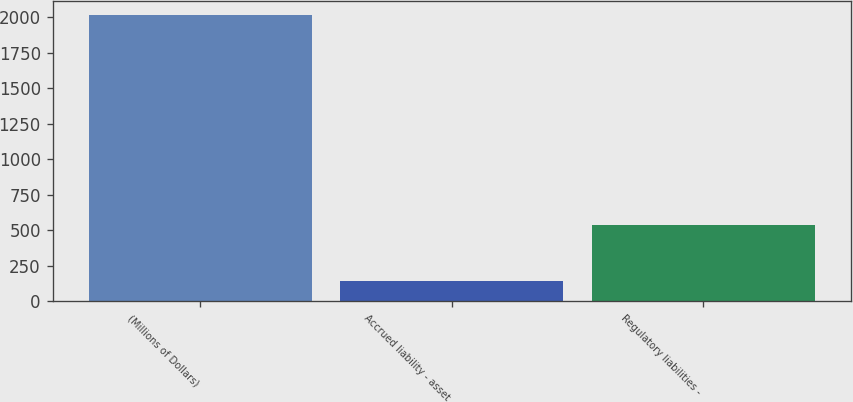Convert chart to OTSL. <chart><loc_0><loc_0><loc_500><loc_500><bar_chart><fcel>(Millions of Dollars)<fcel>Accrued liability - asset<fcel>Regulatory liabilities -<nl><fcel>2013<fcel>143<fcel>540<nl></chart> 